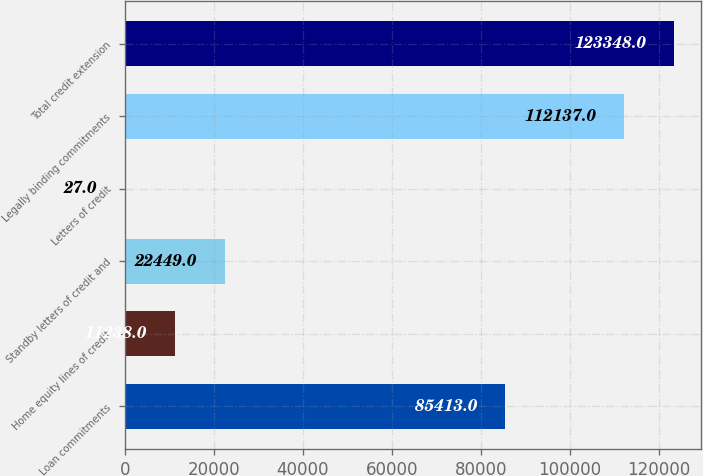<chart> <loc_0><loc_0><loc_500><loc_500><bar_chart><fcel>Loan commitments<fcel>Home equity lines of credit<fcel>Standby letters of credit and<fcel>Letters of credit<fcel>Legally binding commitments<fcel>Total credit extension<nl><fcel>85413<fcel>11238<fcel>22449<fcel>27<fcel>112137<fcel>123348<nl></chart> 